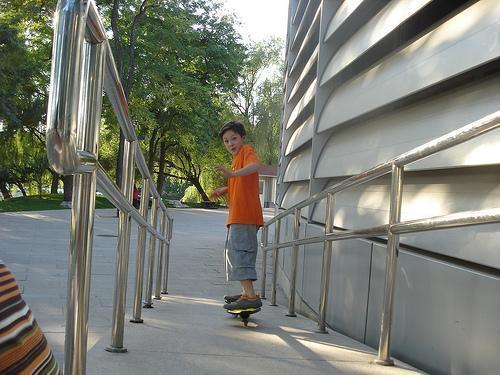How many children are there?
Give a very brief answer. 1. 